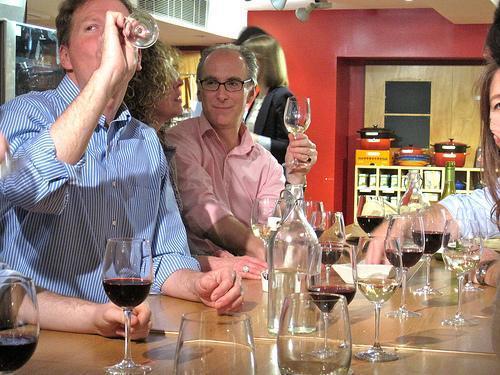How many people are sitting on the left side?
Give a very brief answer. 3. How many glasses on the table have white wine in them?
Give a very brief answer. 3. 